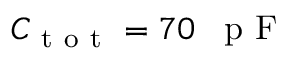Convert formula to latex. <formula><loc_0><loc_0><loc_500><loc_500>C _ { t o t } = 7 0 \, p F</formula> 